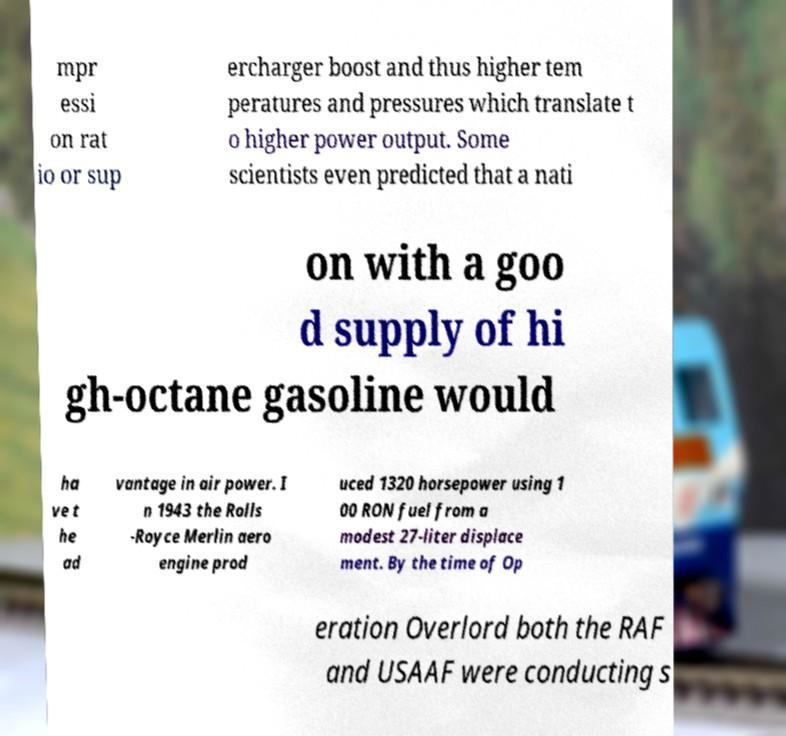Please read and relay the text visible in this image. What does it say? mpr essi on rat io or sup ercharger boost and thus higher tem peratures and pressures which translate t o higher power output. Some scientists even predicted that a nati on with a goo d supply of hi gh-octane gasoline would ha ve t he ad vantage in air power. I n 1943 the Rolls -Royce Merlin aero engine prod uced 1320 horsepower using 1 00 RON fuel from a modest 27-liter displace ment. By the time of Op eration Overlord both the RAF and USAAF were conducting s 